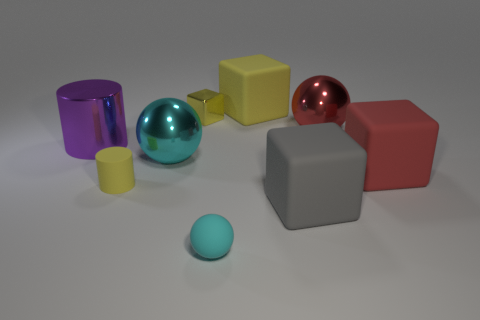Subtract all blue blocks. Subtract all yellow cylinders. How many blocks are left? 4 Add 1 small matte spheres. How many objects exist? 10 Subtract all blocks. How many objects are left? 5 Subtract all big green rubber cubes. Subtract all big purple things. How many objects are left? 8 Add 2 yellow cubes. How many yellow cubes are left? 4 Add 3 small blue metallic spheres. How many small blue metallic spheres exist? 3 Subtract 0 purple balls. How many objects are left? 9 